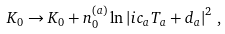<formula> <loc_0><loc_0><loc_500><loc_500>K _ { 0 } \rightarrow K _ { 0 } + n _ { 0 } ^ { ( a ) } \ln \left | i c _ { a } T _ { a } + d _ { a } \right | ^ { 2 } \, ,</formula> 